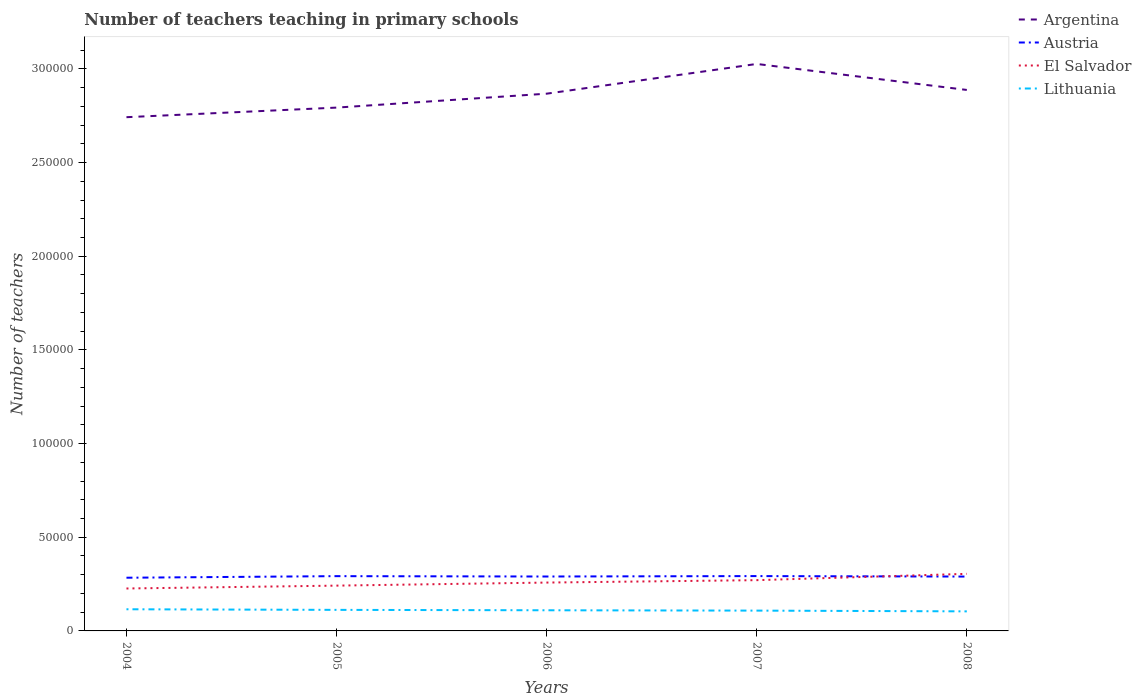How many different coloured lines are there?
Ensure brevity in your answer.  4. Does the line corresponding to Lithuania intersect with the line corresponding to Argentina?
Provide a succinct answer. No. Is the number of lines equal to the number of legend labels?
Keep it short and to the point. Yes. Across all years, what is the maximum number of teachers teaching in primary schools in Argentina?
Your answer should be compact. 2.74e+05. What is the total number of teachers teaching in primary schools in Lithuania in the graph?
Your response must be concise. 181. What is the difference between the highest and the second highest number of teachers teaching in primary schools in Argentina?
Provide a succinct answer. 2.84e+04. What is the difference between the highest and the lowest number of teachers teaching in primary schools in Lithuania?
Offer a very short reply. 3. Is the number of teachers teaching in primary schools in Austria strictly greater than the number of teachers teaching in primary schools in El Salvador over the years?
Make the answer very short. No. Are the values on the major ticks of Y-axis written in scientific E-notation?
Give a very brief answer. No. Does the graph contain any zero values?
Keep it short and to the point. No. Does the graph contain grids?
Provide a succinct answer. No. Where does the legend appear in the graph?
Make the answer very short. Top right. How many legend labels are there?
Provide a short and direct response. 4. How are the legend labels stacked?
Give a very brief answer. Vertical. What is the title of the graph?
Ensure brevity in your answer.  Number of teachers teaching in primary schools. What is the label or title of the X-axis?
Your response must be concise. Years. What is the label or title of the Y-axis?
Your answer should be very brief. Number of teachers. What is the Number of teachers of Argentina in 2004?
Provide a short and direct response. 2.74e+05. What is the Number of teachers of Austria in 2004?
Provide a short and direct response. 2.84e+04. What is the Number of teachers of El Salvador in 2004?
Keep it short and to the point. 2.26e+04. What is the Number of teachers in Lithuania in 2004?
Offer a very short reply. 1.16e+04. What is the Number of teachers of Argentina in 2005?
Provide a succinct answer. 2.79e+05. What is the Number of teachers of Austria in 2005?
Make the answer very short. 2.92e+04. What is the Number of teachers of El Salvador in 2005?
Your answer should be compact. 2.42e+04. What is the Number of teachers in Lithuania in 2005?
Provide a succinct answer. 1.12e+04. What is the Number of teachers of Argentina in 2006?
Offer a very short reply. 2.87e+05. What is the Number of teachers of Austria in 2006?
Offer a terse response. 2.90e+04. What is the Number of teachers in El Salvador in 2006?
Provide a short and direct response. 2.58e+04. What is the Number of teachers in Lithuania in 2006?
Your answer should be very brief. 1.10e+04. What is the Number of teachers of Argentina in 2007?
Offer a terse response. 3.03e+05. What is the Number of teachers in Austria in 2007?
Offer a very short reply. 2.93e+04. What is the Number of teachers in El Salvador in 2007?
Your answer should be compact. 2.71e+04. What is the Number of teachers of Lithuania in 2007?
Provide a short and direct response. 1.08e+04. What is the Number of teachers in Argentina in 2008?
Provide a short and direct response. 2.89e+05. What is the Number of teachers of Austria in 2008?
Keep it short and to the point. 2.90e+04. What is the Number of teachers in El Salvador in 2008?
Provide a succinct answer. 3.05e+04. What is the Number of teachers of Lithuania in 2008?
Provide a short and direct response. 1.04e+04. Across all years, what is the maximum Number of teachers in Argentina?
Ensure brevity in your answer.  3.03e+05. Across all years, what is the maximum Number of teachers in Austria?
Make the answer very short. 2.93e+04. Across all years, what is the maximum Number of teachers in El Salvador?
Ensure brevity in your answer.  3.05e+04. Across all years, what is the maximum Number of teachers in Lithuania?
Provide a succinct answer. 1.16e+04. Across all years, what is the minimum Number of teachers of Argentina?
Offer a very short reply. 2.74e+05. Across all years, what is the minimum Number of teachers of Austria?
Ensure brevity in your answer.  2.84e+04. Across all years, what is the minimum Number of teachers of El Salvador?
Your answer should be compact. 2.26e+04. Across all years, what is the minimum Number of teachers in Lithuania?
Provide a succinct answer. 1.04e+04. What is the total Number of teachers in Argentina in the graph?
Your response must be concise. 1.43e+06. What is the total Number of teachers in Austria in the graph?
Provide a short and direct response. 1.45e+05. What is the total Number of teachers in El Salvador in the graph?
Offer a terse response. 1.30e+05. What is the total Number of teachers in Lithuania in the graph?
Keep it short and to the point. 5.51e+04. What is the difference between the Number of teachers in Argentina in 2004 and that in 2005?
Your answer should be very brief. -5117. What is the difference between the Number of teachers in Austria in 2004 and that in 2005?
Ensure brevity in your answer.  -842. What is the difference between the Number of teachers of El Salvador in 2004 and that in 2005?
Your answer should be very brief. -1530. What is the difference between the Number of teachers in Lithuania in 2004 and that in 2005?
Keep it short and to the point. 324. What is the difference between the Number of teachers of Argentina in 2004 and that in 2006?
Offer a very short reply. -1.26e+04. What is the difference between the Number of teachers of Austria in 2004 and that in 2006?
Your response must be concise. -647. What is the difference between the Number of teachers of El Salvador in 2004 and that in 2006?
Keep it short and to the point. -3164. What is the difference between the Number of teachers of Lithuania in 2004 and that in 2006?
Give a very brief answer. 537. What is the difference between the Number of teachers of Argentina in 2004 and that in 2007?
Provide a short and direct response. -2.84e+04. What is the difference between the Number of teachers of Austria in 2004 and that in 2007?
Offer a very short reply. -877. What is the difference between the Number of teachers of El Salvador in 2004 and that in 2007?
Keep it short and to the point. -4449. What is the difference between the Number of teachers in Lithuania in 2004 and that in 2007?
Ensure brevity in your answer.  718. What is the difference between the Number of teachers in Argentina in 2004 and that in 2008?
Ensure brevity in your answer.  -1.45e+04. What is the difference between the Number of teachers of Austria in 2004 and that in 2008?
Give a very brief answer. -620. What is the difference between the Number of teachers of El Salvador in 2004 and that in 2008?
Your answer should be very brief. -7825. What is the difference between the Number of teachers in Lithuania in 2004 and that in 2008?
Give a very brief answer. 1120. What is the difference between the Number of teachers of Argentina in 2005 and that in 2006?
Your answer should be compact. -7433. What is the difference between the Number of teachers in Austria in 2005 and that in 2006?
Give a very brief answer. 195. What is the difference between the Number of teachers of El Salvador in 2005 and that in 2006?
Your answer should be compact. -1634. What is the difference between the Number of teachers of Lithuania in 2005 and that in 2006?
Make the answer very short. 213. What is the difference between the Number of teachers in Argentina in 2005 and that in 2007?
Make the answer very short. -2.33e+04. What is the difference between the Number of teachers of Austria in 2005 and that in 2007?
Make the answer very short. -35. What is the difference between the Number of teachers in El Salvador in 2005 and that in 2007?
Offer a terse response. -2919. What is the difference between the Number of teachers in Lithuania in 2005 and that in 2007?
Keep it short and to the point. 394. What is the difference between the Number of teachers of Argentina in 2005 and that in 2008?
Your answer should be compact. -9427. What is the difference between the Number of teachers in Austria in 2005 and that in 2008?
Give a very brief answer. 222. What is the difference between the Number of teachers in El Salvador in 2005 and that in 2008?
Make the answer very short. -6295. What is the difference between the Number of teachers of Lithuania in 2005 and that in 2008?
Keep it short and to the point. 796. What is the difference between the Number of teachers of Argentina in 2006 and that in 2007?
Your answer should be very brief. -1.59e+04. What is the difference between the Number of teachers in Austria in 2006 and that in 2007?
Your answer should be compact. -230. What is the difference between the Number of teachers in El Salvador in 2006 and that in 2007?
Ensure brevity in your answer.  -1285. What is the difference between the Number of teachers in Lithuania in 2006 and that in 2007?
Ensure brevity in your answer.  181. What is the difference between the Number of teachers in Argentina in 2006 and that in 2008?
Offer a terse response. -1994. What is the difference between the Number of teachers in Austria in 2006 and that in 2008?
Offer a very short reply. 27. What is the difference between the Number of teachers in El Salvador in 2006 and that in 2008?
Offer a very short reply. -4661. What is the difference between the Number of teachers in Lithuania in 2006 and that in 2008?
Your response must be concise. 583. What is the difference between the Number of teachers in Argentina in 2007 and that in 2008?
Offer a terse response. 1.39e+04. What is the difference between the Number of teachers in Austria in 2007 and that in 2008?
Ensure brevity in your answer.  257. What is the difference between the Number of teachers in El Salvador in 2007 and that in 2008?
Your answer should be compact. -3376. What is the difference between the Number of teachers of Lithuania in 2007 and that in 2008?
Keep it short and to the point. 402. What is the difference between the Number of teachers of Argentina in 2004 and the Number of teachers of Austria in 2005?
Make the answer very short. 2.45e+05. What is the difference between the Number of teachers in Argentina in 2004 and the Number of teachers in El Salvador in 2005?
Provide a succinct answer. 2.50e+05. What is the difference between the Number of teachers of Argentina in 2004 and the Number of teachers of Lithuania in 2005?
Your answer should be very brief. 2.63e+05. What is the difference between the Number of teachers of Austria in 2004 and the Number of teachers of El Salvador in 2005?
Offer a very short reply. 4218. What is the difference between the Number of teachers in Austria in 2004 and the Number of teachers in Lithuania in 2005?
Keep it short and to the point. 1.72e+04. What is the difference between the Number of teachers of El Salvador in 2004 and the Number of teachers of Lithuania in 2005?
Provide a short and direct response. 1.14e+04. What is the difference between the Number of teachers of Argentina in 2004 and the Number of teachers of Austria in 2006?
Keep it short and to the point. 2.45e+05. What is the difference between the Number of teachers in Argentina in 2004 and the Number of teachers in El Salvador in 2006?
Provide a succinct answer. 2.48e+05. What is the difference between the Number of teachers of Argentina in 2004 and the Number of teachers of Lithuania in 2006?
Give a very brief answer. 2.63e+05. What is the difference between the Number of teachers in Austria in 2004 and the Number of teachers in El Salvador in 2006?
Your answer should be compact. 2584. What is the difference between the Number of teachers in Austria in 2004 and the Number of teachers in Lithuania in 2006?
Provide a short and direct response. 1.74e+04. What is the difference between the Number of teachers of El Salvador in 2004 and the Number of teachers of Lithuania in 2006?
Keep it short and to the point. 1.16e+04. What is the difference between the Number of teachers in Argentina in 2004 and the Number of teachers in Austria in 2007?
Provide a short and direct response. 2.45e+05. What is the difference between the Number of teachers in Argentina in 2004 and the Number of teachers in El Salvador in 2007?
Keep it short and to the point. 2.47e+05. What is the difference between the Number of teachers of Argentina in 2004 and the Number of teachers of Lithuania in 2007?
Your answer should be compact. 2.63e+05. What is the difference between the Number of teachers in Austria in 2004 and the Number of teachers in El Salvador in 2007?
Keep it short and to the point. 1299. What is the difference between the Number of teachers of Austria in 2004 and the Number of teachers of Lithuania in 2007?
Give a very brief answer. 1.76e+04. What is the difference between the Number of teachers in El Salvador in 2004 and the Number of teachers in Lithuania in 2007?
Make the answer very short. 1.18e+04. What is the difference between the Number of teachers in Argentina in 2004 and the Number of teachers in Austria in 2008?
Your response must be concise. 2.45e+05. What is the difference between the Number of teachers of Argentina in 2004 and the Number of teachers of El Salvador in 2008?
Your answer should be compact. 2.44e+05. What is the difference between the Number of teachers of Argentina in 2004 and the Number of teachers of Lithuania in 2008?
Ensure brevity in your answer.  2.64e+05. What is the difference between the Number of teachers in Austria in 2004 and the Number of teachers in El Salvador in 2008?
Provide a succinct answer. -2077. What is the difference between the Number of teachers of Austria in 2004 and the Number of teachers of Lithuania in 2008?
Provide a succinct answer. 1.80e+04. What is the difference between the Number of teachers in El Salvador in 2004 and the Number of teachers in Lithuania in 2008?
Offer a very short reply. 1.22e+04. What is the difference between the Number of teachers in Argentina in 2005 and the Number of teachers in Austria in 2006?
Provide a succinct answer. 2.50e+05. What is the difference between the Number of teachers in Argentina in 2005 and the Number of teachers in El Salvador in 2006?
Offer a terse response. 2.54e+05. What is the difference between the Number of teachers in Argentina in 2005 and the Number of teachers in Lithuania in 2006?
Ensure brevity in your answer.  2.68e+05. What is the difference between the Number of teachers of Austria in 2005 and the Number of teachers of El Salvador in 2006?
Your answer should be very brief. 3426. What is the difference between the Number of teachers of Austria in 2005 and the Number of teachers of Lithuania in 2006?
Your answer should be compact. 1.82e+04. What is the difference between the Number of teachers in El Salvador in 2005 and the Number of teachers in Lithuania in 2006?
Ensure brevity in your answer.  1.32e+04. What is the difference between the Number of teachers of Argentina in 2005 and the Number of teachers of Austria in 2007?
Provide a short and direct response. 2.50e+05. What is the difference between the Number of teachers of Argentina in 2005 and the Number of teachers of El Salvador in 2007?
Offer a very short reply. 2.52e+05. What is the difference between the Number of teachers of Argentina in 2005 and the Number of teachers of Lithuania in 2007?
Your answer should be compact. 2.69e+05. What is the difference between the Number of teachers in Austria in 2005 and the Number of teachers in El Salvador in 2007?
Offer a terse response. 2141. What is the difference between the Number of teachers of Austria in 2005 and the Number of teachers of Lithuania in 2007?
Give a very brief answer. 1.84e+04. What is the difference between the Number of teachers of El Salvador in 2005 and the Number of teachers of Lithuania in 2007?
Give a very brief answer. 1.33e+04. What is the difference between the Number of teachers of Argentina in 2005 and the Number of teachers of Austria in 2008?
Your answer should be very brief. 2.50e+05. What is the difference between the Number of teachers in Argentina in 2005 and the Number of teachers in El Salvador in 2008?
Provide a succinct answer. 2.49e+05. What is the difference between the Number of teachers in Argentina in 2005 and the Number of teachers in Lithuania in 2008?
Give a very brief answer. 2.69e+05. What is the difference between the Number of teachers of Austria in 2005 and the Number of teachers of El Salvador in 2008?
Make the answer very short. -1235. What is the difference between the Number of teachers in Austria in 2005 and the Number of teachers in Lithuania in 2008?
Give a very brief answer. 1.88e+04. What is the difference between the Number of teachers in El Salvador in 2005 and the Number of teachers in Lithuania in 2008?
Keep it short and to the point. 1.37e+04. What is the difference between the Number of teachers of Argentina in 2006 and the Number of teachers of Austria in 2007?
Keep it short and to the point. 2.58e+05. What is the difference between the Number of teachers of Argentina in 2006 and the Number of teachers of El Salvador in 2007?
Offer a very short reply. 2.60e+05. What is the difference between the Number of teachers in Argentina in 2006 and the Number of teachers in Lithuania in 2007?
Offer a terse response. 2.76e+05. What is the difference between the Number of teachers in Austria in 2006 and the Number of teachers in El Salvador in 2007?
Your response must be concise. 1946. What is the difference between the Number of teachers of Austria in 2006 and the Number of teachers of Lithuania in 2007?
Provide a short and direct response. 1.82e+04. What is the difference between the Number of teachers of El Salvador in 2006 and the Number of teachers of Lithuania in 2007?
Offer a terse response. 1.50e+04. What is the difference between the Number of teachers in Argentina in 2006 and the Number of teachers in Austria in 2008?
Give a very brief answer. 2.58e+05. What is the difference between the Number of teachers in Argentina in 2006 and the Number of teachers in El Salvador in 2008?
Ensure brevity in your answer.  2.56e+05. What is the difference between the Number of teachers of Argentina in 2006 and the Number of teachers of Lithuania in 2008?
Give a very brief answer. 2.76e+05. What is the difference between the Number of teachers in Austria in 2006 and the Number of teachers in El Salvador in 2008?
Ensure brevity in your answer.  -1430. What is the difference between the Number of teachers in Austria in 2006 and the Number of teachers in Lithuania in 2008?
Offer a very short reply. 1.86e+04. What is the difference between the Number of teachers in El Salvador in 2006 and the Number of teachers in Lithuania in 2008?
Keep it short and to the point. 1.54e+04. What is the difference between the Number of teachers of Argentina in 2007 and the Number of teachers of Austria in 2008?
Provide a short and direct response. 2.74e+05. What is the difference between the Number of teachers in Argentina in 2007 and the Number of teachers in El Salvador in 2008?
Give a very brief answer. 2.72e+05. What is the difference between the Number of teachers in Argentina in 2007 and the Number of teachers in Lithuania in 2008?
Your response must be concise. 2.92e+05. What is the difference between the Number of teachers in Austria in 2007 and the Number of teachers in El Salvador in 2008?
Provide a short and direct response. -1200. What is the difference between the Number of teachers in Austria in 2007 and the Number of teachers in Lithuania in 2008?
Provide a short and direct response. 1.88e+04. What is the difference between the Number of teachers in El Salvador in 2007 and the Number of teachers in Lithuania in 2008?
Ensure brevity in your answer.  1.67e+04. What is the average Number of teachers in Argentina per year?
Keep it short and to the point. 2.86e+05. What is the average Number of teachers of Austria per year?
Offer a terse response. 2.90e+04. What is the average Number of teachers of El Salvador per year?
Your answer should be very brief. 2.60e+04. What is the average Number of teachers in Lithuania per year?
Your answer should be compact. 1.10e+04. In the year 2004, what is the difference between the Number of teachers of Argentina and Number of teachers of Austria?
Offer a very short reply. 2.46e+05. In the year 2004, what is the difference between the Number of teachers in Argentina and Number of teachers in El Salvador?
Keep it short and to the point. 2.52e+05. In the year 2004, what is the difference between the Number of teachers of Argentina and Number of teachers of Lithuania?
Keep it short and to the point. 2.63e+05. In the year 2004, what is the difference between the Number of teachers of Austria and Number of teachers of El Salvador?
Ensure brevity in your answer.  5748. In the year 2004, what is the difference between the Number of teachers in Austria and Number of teachers in Lithuania?
Ensure brevity in your answer.  1.68e+04. In the year 2004, what is the difference between the Number of teachers in El Salvador and Number of teachers in Lithuania?
Ensure brevity in your answer.  1.11e+04. In the year 2005, what is the difference between the Number of teachers of Argentina and Number of teachers of Austria?
Offer a very short reply. 2.50e+05. In the year 2005, what is the difference between the Number of teachers in Argentina and Number of teachers in El Salvador?
Your response must be concise. 2.55e+05. In the year 2005, what is the difference between the Number of teachers of Argentina and Number of teachers of Lithuania?
Your answer should be very brief. 2.68e+05. In the year 2005, what is the difference between the Number of teachers in Austria and Number of teachers in El Salvador?
Ensure brevity in your answer.  5060. In the year 2005, what is the difference between the Number of teachers in Austria and Number of teachers in Lithuania?
Your response must be concise. 1.80e+04. In the year 2005, what is the difference between the Number of teachers in El Salvador and Number of teachers in Lithuania?
Your response must be concise. 1.29e+04. In the year 2006, what is the difference between the Number of teachers of Argentina and Number of teachers of Austria?
Provide a succinct answer. 2.58e+05. In the year 2006, what is the difference between the Number of teachers of Argentina and Number of teachers of El Salvador?
Offer a terse response. 2.61e+05. In the year 2006, what is the difference between the Number of teachers of Argentina and Number of teachers of Lithuania?
Give a very brief answer. 2.76e+05. In the year 2006, what is the difference between the Number of teachers in Austria and Number of teachers in El Salvador?
Offer a very short reply. 3231. In the year 2006, what is the difference between the Number of teachers in Austria and Number of teachers in Lithuania?
Your response must be concise. 1.80e+04. In the year 2006, what is the difference between the Number of teachers of El Salvador and Number of teachers of Lithuania?
Ensure brevity in your answer.  1.48e+04. In the year 2007, what is the difference between the Number of teachers of Argentina and Number of teachers of Austria?
Keep it short and to the point. 2.73e+05. In the year 2007, what is the difference between the Number of teachers of Argentina and Number of teachers of El Salvador?
Your response must be concise. 2.76e+05. In the year 2007, what is the difference between the Number of teachers of Argentina and Number of teachers of Lithuania?
Ensure brevity in your answer.  2.92e+05. In the year 2007, what is the difference between the Number of teachers in Austria and Number of teachers in El Salvador?
Provide a succinct answer. 2176. In the year 2007, what is the difference between the Number of teachers in Austria and Number of teachers in Lithuania?
Make the answer very short. 1.84e+04. In the year 2007, what is the difference between the Number of teachers of El Salvador and Number of teachers of Lithuania?
Your response must be concise. 1.63e+04. In the year 2008, what is the difference between the Number of teachers in Argentina and Number of teachers in Austria?
Provide a short and direct response. 2.60e+05. In the year 2008, what is the difference between the Number of teachers in Argentina and Number of teachers in El Salvador?
Give a very brief answer. 2.58e+05. In the year 2008, what is the difference between the Number of teachers in Argentina and Number of teachers in Lithuania?
Offer a terse response. 2.78e+05. In the year 2008, what is the difference between the Number of teachers in Austria and Number of teachers in El Salvador?
Your answer should be compact. -1457. In the year 2008, what is the difference between the Number of teachers of Austria and Number of teachers of Lithuania?
Keep it short and to the point. 1.86e+04. In the year 2008, what is the difference between the Number of teachers of El Salvador and Number of teachers of Lithuania?
Your response must be concise. 2.00e+04. What is the ratio of the Number of teachers of Argentina in 2004 to that in 2005?
Keep it short and to the point. 0.98. What is the ratio of the Number of teachers of Austria in 2004 to that in 2005?
Your answer should be compact. 0.97. What is the ratio of the Number of teachers in El Salvador in 2004 to that in 2005?
Provide a short and direct response. 0.94. What is the ratio of the Number of teachers in Lithuania in 2004 to that in 2005?
Your answer should be very brief. 1.03. What is the ratio of the Number of teachers of Argentina in 2004 to that in 2006?
Make the answer very short. 0.96. What is the ratio of the Number of teachers in Austria in 2004 to that in 2006?
Give a very brief answer. 0.98. What is the ratio of the Number of teachers in El Salvador in 2004 to that in 2006?
Ensure brevity in your answer.  0.88. What is the ratio of the Number of teachers in Lithuania in 2004 to that in 2006?
Make the answer very short. 1.05. What is the ratio of the Number of teachers of Argentina in 2004 to that in 2007?
Your response must be concise. 0.91. What is the ratio of the Number of teachers of Austria in 2004 to that in 2007?
Ensure brevity in your answer.  0.97. What is the ratio of the Number of teachers of El Salvador in 2004 to that in 2007?
Offer a very short reply. 0.84. What is the ratio of the Number of teachers of Lithuania in 2004 to that in 2007?
Offer a terse response. 1.07. What is the ratio of the Number of teachers in Argentina in 2004 to that in 2008?
Give a very brief answer. 0.95. What is the ratio of the Number of teachers in Austria in 2004 to that in 2008?
Your response must be concise. 0.98. What is the ratio of the Number of teachers of El Salvador in 2004 to that in 2008?
Offer a terse response. 0.74. What is the ratio of the Number of teachers in Lithuania in 2004 to that in 2008?
Keep it short and to the point. 1.11. What is the ratio of the Number of teachers of Argentina in 2005 to that in 2006?
Provide a succinct answer. 0.97. What is the ratio of the Number of teachers of Austria in 2005 to that in 2006?
Keep it short and to the point. 1.01. What is the ratio of the Number of teachers of El Salvador in 2005 to that in 2006?
Your response must be concise. 0.94. What is the ratio of the Number of teachers in Lithuania in 2005 to that in 2006?
Provide a short and direct response. 1.02. What is the ratio of the Number of teachers in Argentina in 2005 to that in 2007?
Provide a short and direct response. 0.92. What is the ratio of the Number of teachers in Austria in 2005 to that in 2007?
Make the answer very short. 1. What is the ratio of the Number of teachers in El Salvador in 2005 to that in 2007?
Offer a very short reply. 0.89. What is the ratio of the Number of teachers in Lithuania in 2005 to that in 2007?
Your response must be concise. 1.04. What is the ratio of the Number of teachers in Argentina in 2005 to that in 2008?
Provide a succinct answer. 0.97. What is the ratio of the Number of teachers of Austria in 2005 to that in 2008?
Give a very brief answer. 1.01. What is the ratio of the Number of teachers in El Salvador in 2005 to that in 2008?
Keep it short and to the point. 0.79. What is the ratio of the Number of teachers of Lithuania in 2005 to that in 2008?
Your response must be concise. 1.08. What is the ratio of the Number of teachers in Argentina in 2006 to that in 2007?
Your answer should be very brief. 0.95. What is the ratio of the Number of teachers in El Salvador in 2006 to that in 2007?
Keep it short and to the point. 0.95. What is the ratio of the Number of teachers of Lithuania in 2006 to that in 2007?
Provide a short and direct response. 1.02. What is the ratio of the Number of teachers in El Salvador in 2006 to that in 2008?
Your answer should be compact. 0.85. What is the ratio of the Number of teachers of Lithuania in 2006 to that in 2008?
Make the answer very short. 1.06. What is the ratio of the Number of teachers of Argentina in 2007 to that in 2008?
Keep it short and to the point. 1.05. What is the ratio of the Number of teachers of Austria in 2007 to that in 2008?
Offer a very short reply. 1.01. What is the ratio of the Number of teachers of El Salvador in 2007 to that in 2008?
Your answer should be compact. 0.89. What is the ratio of the Number of teachers in Lithuania in 2007 to that in 2008?
Your answer should be very brief. 1.04. What is the difference between the highest and the second highest Number of teachers in Argentina?
Make the answer very short. 1.39e+04. What is the difference between the highest and the second highest Number of teachers in El Salvador?
Make the answer very short. 3376. What is the difference between the highest and the second highest Number of teachers in Lithuania?
Your answer should be compact. 324. What is the difference between the highest and the lowest Number of teachers of Argentina?
Your answer should be compact. 2.84e+04. What is the difference between the highest and the lowest Number of teachers of Austria?
Offer a very short reply. 877. What is the difference between the highest and the lowest Number of teachers of El Salvador?
Provide a short and direct response. 7825. What is the difference between the highest and the lowest Number of teachers in Lithuania?
Your answer should be very brief. 1120. 